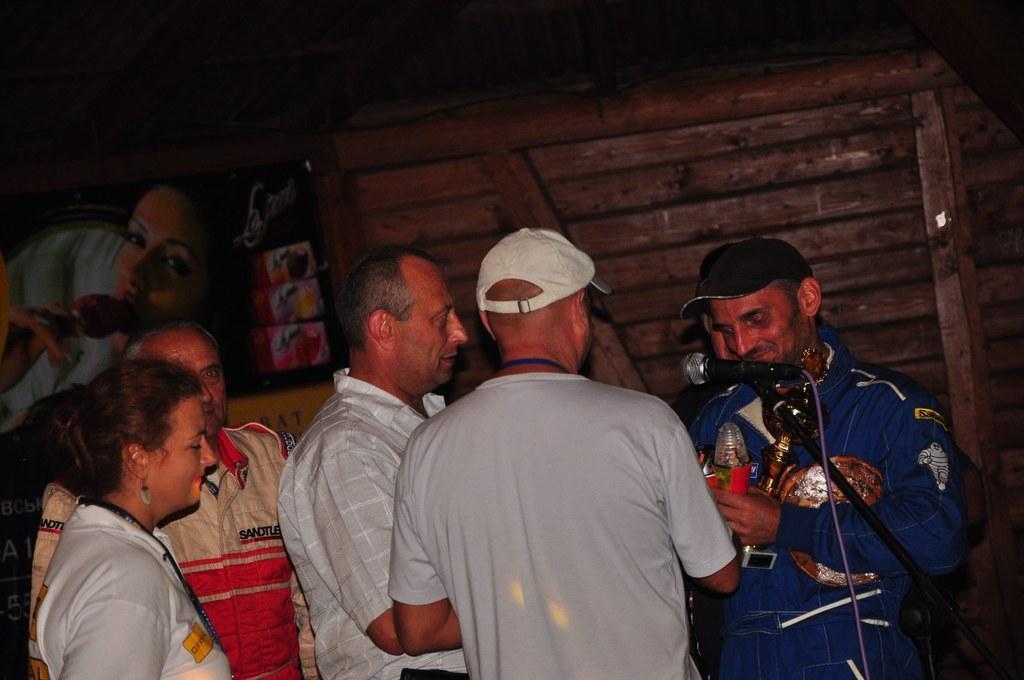In one or two sentences, can you explain what this image depicts? In this image I can see the group of people with different color dresses. I can see two people with the caps. These people are standing in-front of the mic. In the background I can see the board to wooden wall. 